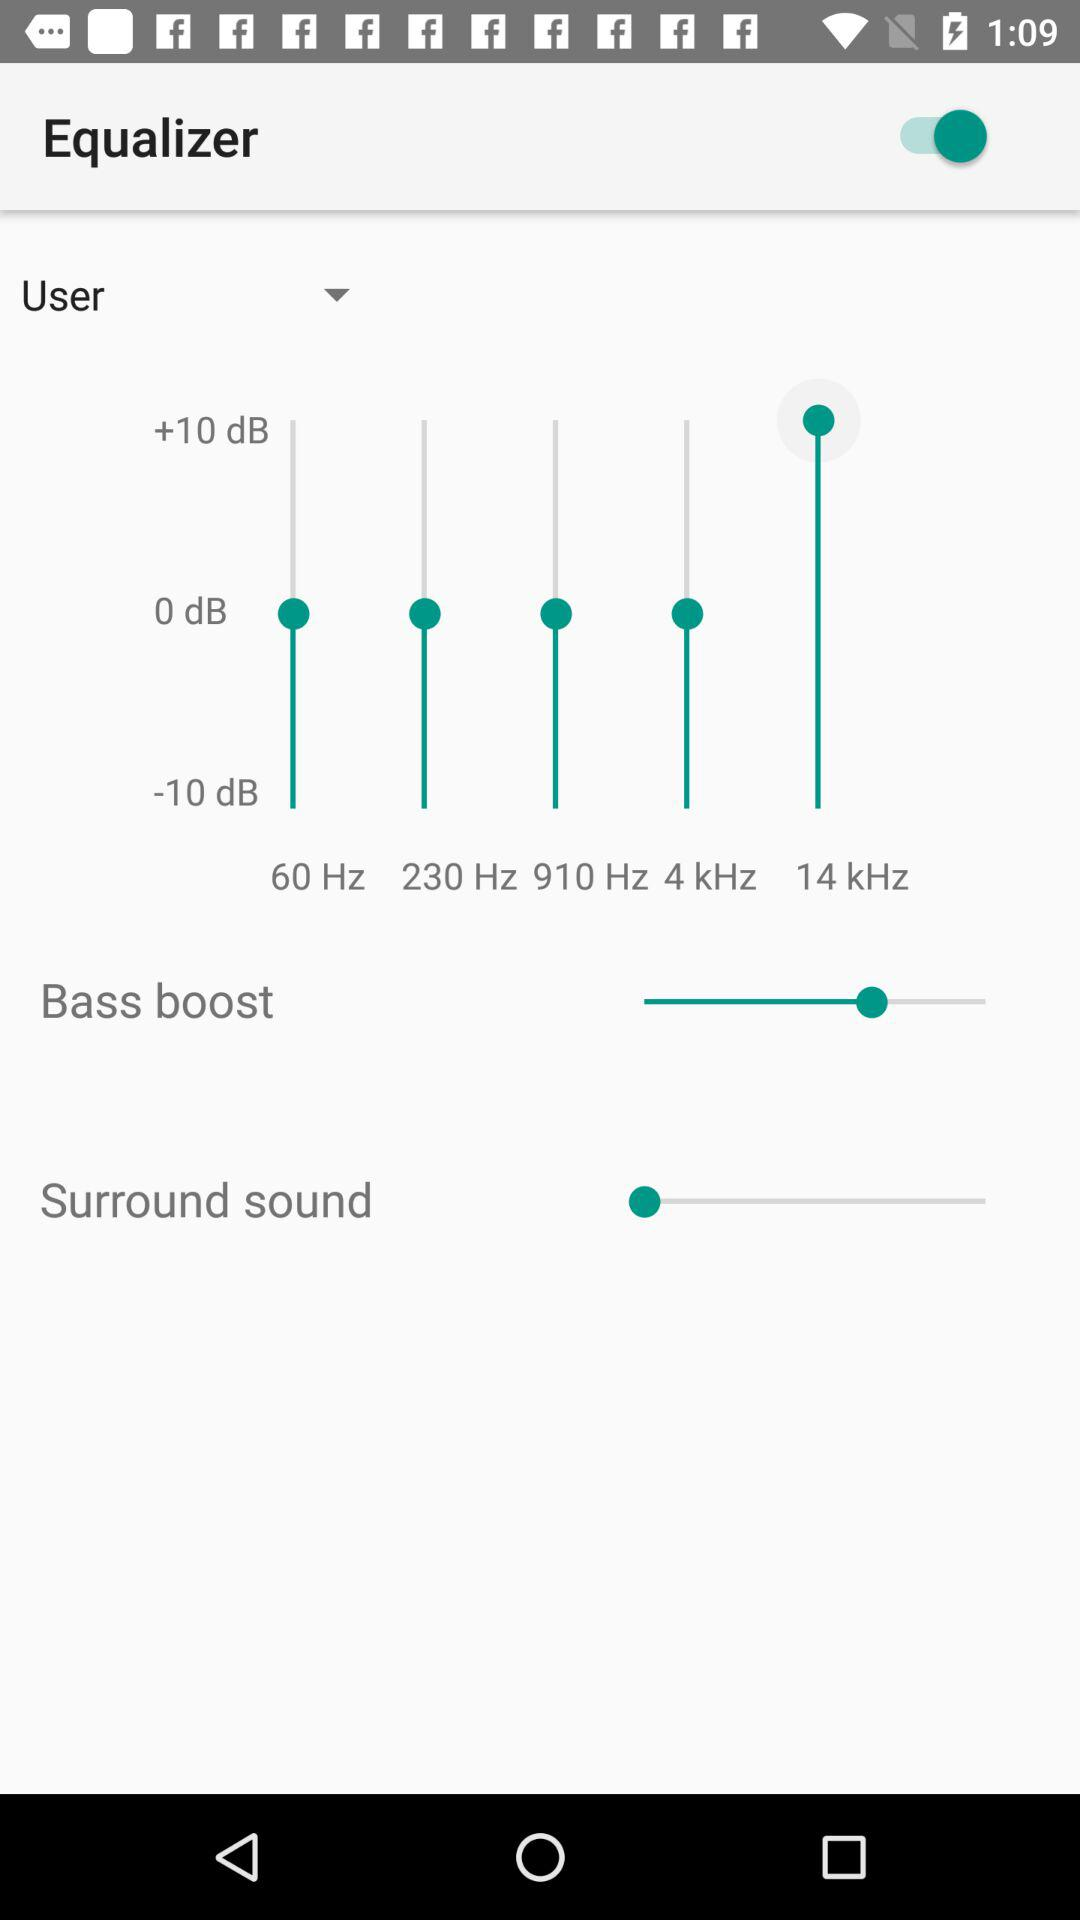What is the status of "Equalizer"? The status is "on". 